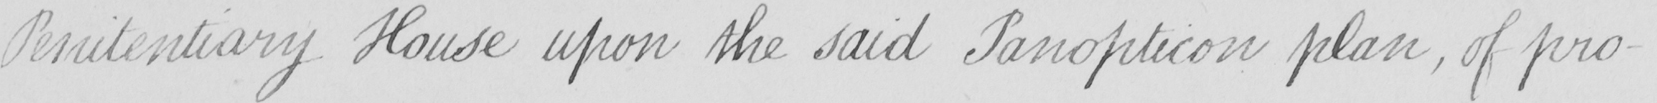Can you tell me what this handwritten text says? Penitentiary House upon the said Panopticon plan , of pro- 